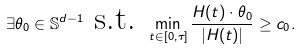<formula> <loc_0><loc_0><loc_500><loc_500>\exists \theta _ { 0 } \in \mathbb { S } ^ { d - 1 } \ \text {s.t.} \ \min _ { t \in [ 0 , \tau ] } \frac { H ( t ) \cdot \theta _ { 0 } } { | H ( t ) | } \geq c _ { 0 } .</formula> 